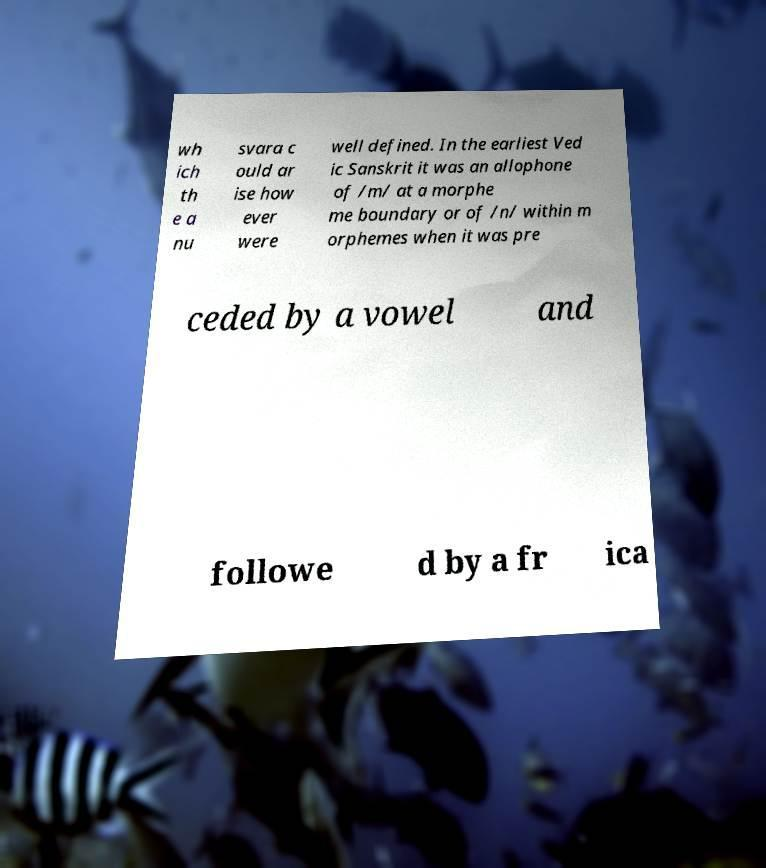What messages or text are displayed in this image? I need them in a readable, typed format. wh ich th e a nu svara c ould ar ise how ever were well defined. In the earliest Ved ic Sanskrit it was an allophone of /m/ at a morphe me boundary or of /n/ within m orphemes when it was pre ceded by a vowel and followe d by a fr ica 